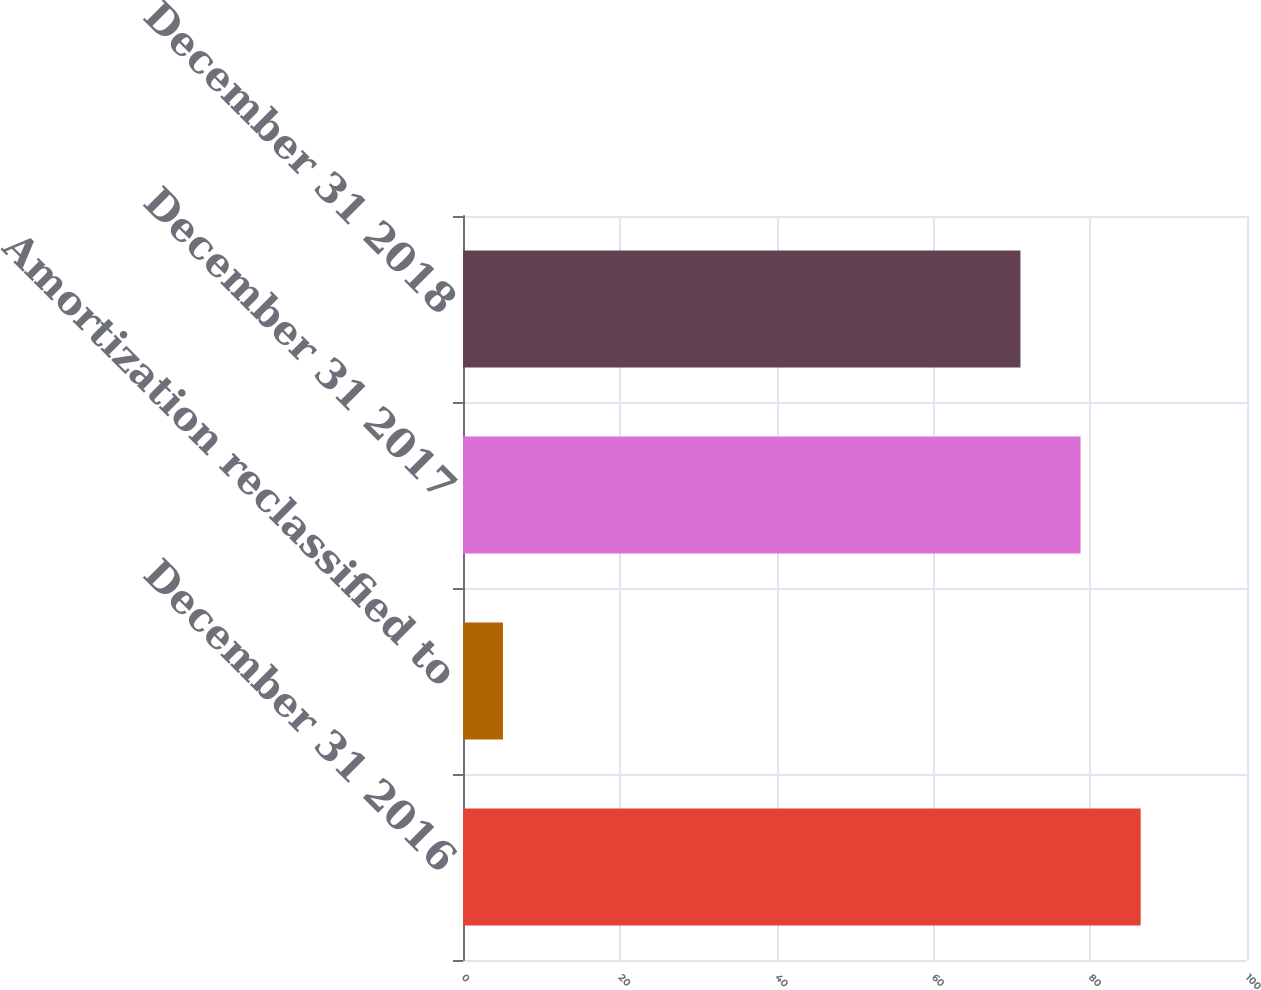<chart> <loc_0><loc_0><loc_500><loc_500><bar_chart><fcel>December 31 2016<fcel>Amortization reclassified to<fcel>December 31 2017<fcel>December 31 2018<nl><fcel>86.44<fcel>5.1<fcel>78.77<fcel>71.1<nl></chart> 